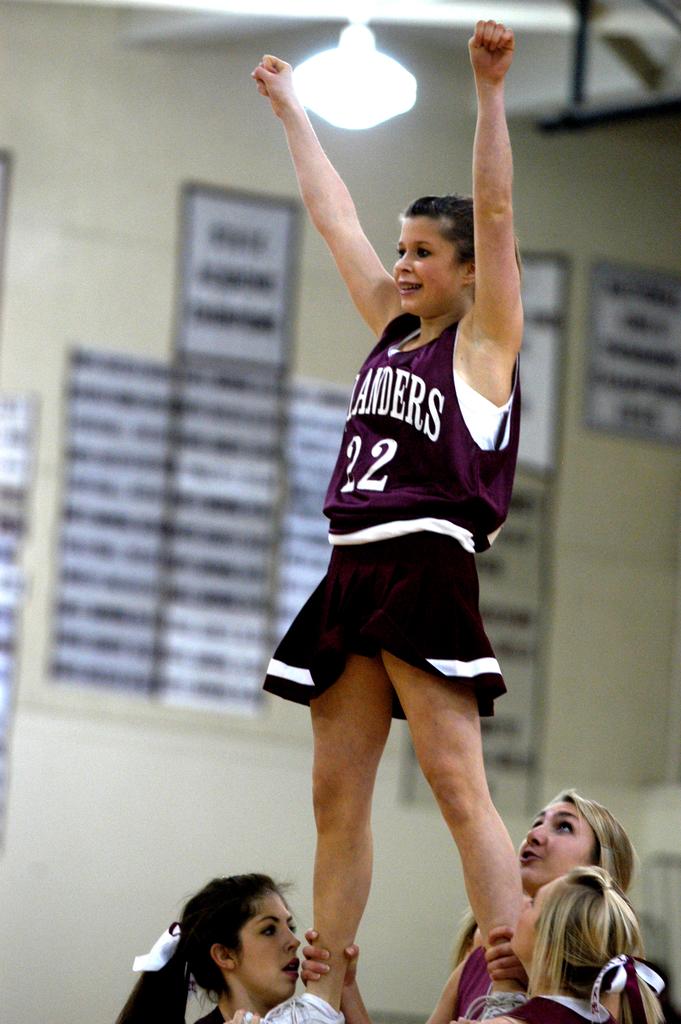What number is this cheerleader?
Provide a short and direct response. 22. How many arms is the cheerleader holding up?
Ensure brevity in your answer.  Answering does not require reading text in the image. 